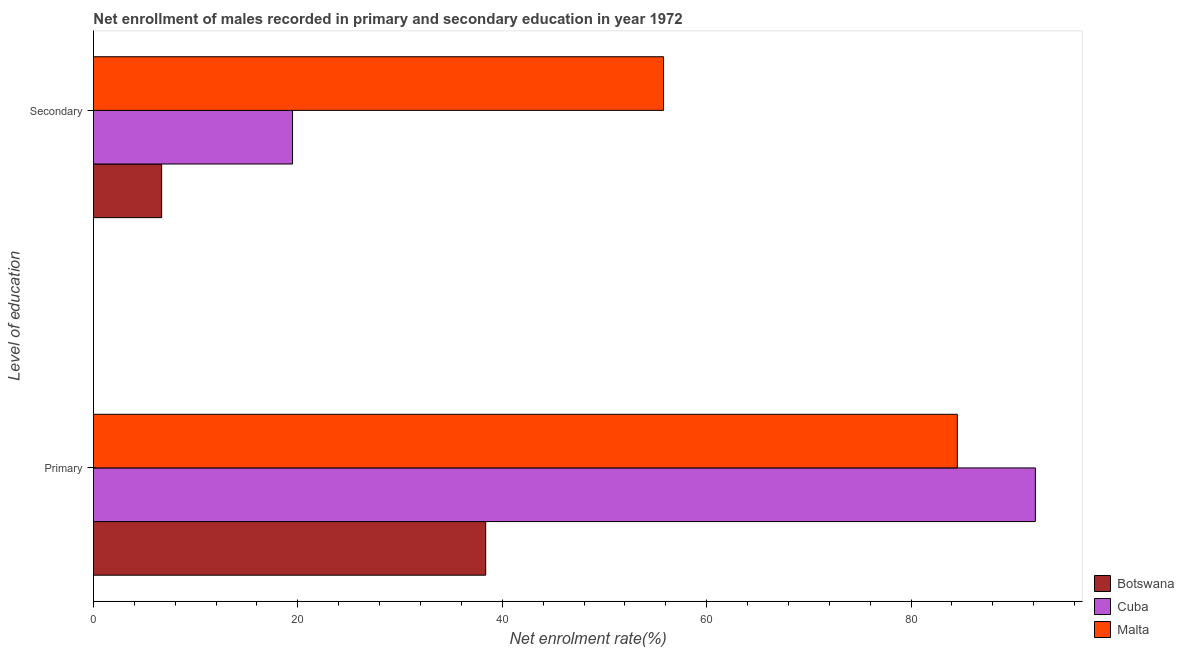How many different coloured bars are there?
Give a very brief answer. 3. How many groups of bars are there?
Your answer should be compact. 2. Are the number of bars on each tick of the Y-axis equal?
Provide a short and direct response. Yes. How many bars are there on the 2nd tick from the top?
Your answer should be very brief. 3. What is the label of the 1st group of bars from the top?
Give a very brief answer. Secondary. What is the enrollment rate in secondary education in Cuba?
Give a very brief answer. 19.48. Across all countries, what is the maximum enrollment rate in secondary education?
Provide a short and direct response. 55.78. Across all countries, what is the minimum enrollment rate in secondary education?
Ensure brevity in your answer.  6.67. In which country was the enrollment rate in secondary education maximum?
Give a very brief answer. Malta. In which country was the enrollment rate in secondary education minimum?
Ensure brevity in your answer.  Botswana. What is the total enrollment rate in secondary education in the graph?
Your answer should be very brief. 81.93. What is the difference between the enrollment rate in secondary education in Malta and that in Botswana?
Offer a terse response. 49.11. What is the difference between the enrollment rate in secondary education in Malta and the enrollment rate in primary education in Botswana?
Provide a succinct answer. 17.4. What is the average enrollment rate in secondary education per country?
Make the answer very short. 27.31. What is the difference between the enrollment rate in primary education and enrollment rate in secondary education in Malta?
Keep it short and to the point. 28.74. In how many countries, is the enrollment rate in secondary education greater than 4 %?
Offer a terse response. 3. What is the ratio of the enrollment rate in primary education in Malta to that in Botswana?
Your answer should be very brief. 2.2. Is the enrollment rate in secondary education in Cuba less than that in Botswana?
Make the answer very short. No. In how many countries, is the enrollment rate in primary education greater than the average enrollment rate in primary education taken over all countries?
Give a very brief answer. 2. What does the 1st bar from the top in Secondary represents?
Give a very brief answer. Malta. What does the 3rd bar from the bottom in Secondary represents?
Offer a very short reply. Malta. How many bars are there?
Your response must be concise. 6. How many countries are there in the graph?
Ensure brevity in your answer.  3. What is the difference between two consecutive major ticks on the X-axis?
Offer a very short reply. 20. Are the values on the major ticks of X-axis written in scientific E-notation?
Make the answer very short. No. Does the graph contain grids?
Provide a short and direct response. No. Where does the legend appear in the graph?
Your answer should be compact. Bottom right. How many legend labels are there?
Keep it short and to the point. 3. What is the title of the graph?
Offer a terse response. Net enrollment of males recorded in primary and secondary education in year 1972. What is the label or title of the X-axis?
Provide a succinct answer. Net enrolment rate(%). What is the label or title of the Y-axis?
Your response must be concise. Level of education. What is the Net enrolment rate(%) of Botswana in Primary?
Your answer should be very brief. 38.38. What is the Net enrolment rate(%) of Cuba in Primary?
Provide a succinct answer. 92.16. What is the Net enrolment rate(%) of Malta in Primary?
Your answer should be very brief. 84.52. What is the Net enrolment rate(%) of Botswana in Secondary?
Keep it short and to the point. 6.67. What is the Net enrolment rate(%) in Cuba in Secondary?
Provide a short and direct response. 19.48. What is the Net enrolment rate(%) of Malta in Secondary?
Give a very brief answer. 55.78. Across all Level of education, what is the maximum Net enrolment rate(%) of Botswana?
Offer a terse response. 38.38. Across all Level of education, what is the maximum Net enrolment rate(%) in Cuba?
Provide a short and direct response. 92.16. Across all Level of education, what is the maximum Net enrolment rate(%) of Malta?
Make the answer very short. 84.52. Across all Level of education, what is the minimum Net enrolment rate(%) in Botswana?
Your response must be concise. 6.67. Across all Level of education, what is the minimum Net enrolment rate(%) of Cuba?
Provide a succinct answer. 19.48. Across all Level of education, what is the minimum Net enrolment rate(%) of Malta?
Provide a succinct answer. 55.78. What is the total Net enrolment rate(%) in Botswana in the graph?
Offer a terse response. 45.05. What is the total Net enrolment rate(%) in Cuba in the graph?
Your response must be concise. 111.64. What is the total Net enrolment rate(%) in Malta in the graph?
Provide a short and direct response. 140.3. What is the difference between the Net enrolment rate(%) in Botswana in Primary and that in Secondary?
Offer a very short reply. 31.71. What is the difference between the Net enrolment rate(%) in Cuba in Primary and that in Secondary?
Provide a short and direct response. 72.69. What is the difference between the Net enrolment rate(%) of Malta in Primary and that in Secondary?
Your answer should be very brief. 28.74. What is the difference between the Net enrolment rate(%) in Botswana in Primary and the Net enrolment rate(%) in Cuba in Secondary?
Your answer should be very brief. 18.9. What is the difference between the Net enrolment rate(%) of Botswana in Primary and the Net enrolment rate(%) of Malta in Secondary?
Keep it short and to the point. -17.4. What is the difference between the Net enrolment rate(%) in Cuba in Primary and the Net enrolment rate(%) in Malta in Secondary?
Your answer should be compact. 36.38. What is the average Net enrolment rate(%) in Botswana per Level of education?
Provide a succinct answer. 22.52. What is the average Net enrolment rate(%) in Cuba per Level of education?
Offer a terse response. 55.82. What is the average Net enrolment rate(%) in Malta per Level of education?
Your answer should be very brief. 70.15. What is the difference between the Net enrolment rate(%) in Botswana and Net enrolment rate(%) in Cuba in Primary?
Your answer should be compact. -53.78. What is the difference between the Net enrolment rate(%) in Botswana and Net enrolment rate(%) in Malta in Primary?
Ensure brevity in your answer.  -46.15. What is the difference between the Net enrolment rate(%) in Cuba and Net enrolment rate(%) in Malta in Primary?
Your response must be concise. 7.64. What is the difference between the Net enrolment rate(%) of Botswana and Net enrolment rate(%) of Cuba in Secondary?
Your answer should be very brief. -12.81. What is the difference between the Net enrolment rate(%) in Botswana and Net enrolment rate(%) in Malta in Secondary?
Ensure brevity in your answer.  -49.11. What is the difference between the Net enrolment rate(%) in Cuba and Net enrolment rate(%) in Malta in Secondary?
Your answer should be compact. -36.3. What is the ratio of the Net enrolment rate(%) of Botswana in Primary to that in Secondary?
Make the answer very short. 5.75. What is the ratio of the Net enrolment rate(%) in Cuba in Primary to that in Secondary?
Your response must be concise. 4.73. What is the ratio of the Net enrolment rate(%) of Malta in Primary to that in Secondary?
Provide a short and direct response. 1.52. What is the difference between the highest and the second highest Net enrolment rate(%) of Botswana?
Ensure brevity in your answer.  31.71. What is the difference between the highest and the second highest Net enrolment rate(%) of Cuba?
Offer a very short reply. 72.69. What is the difference between the highest and the second highest Net enrolment rate(%) of Malta?
Your answer should be compact. 28.74. What is the difference between the highest and the lowest Net enrolment rate(%) in Botswana?
Your response must be concise. 31.71. What is the difference between the highest and the lowest Net enrolment rate(%) in Cuba?
Give a very brief answer. 72.69. What is the difference between the highest and the lowest Net enrolment rate(%) in Malta?
Your answer should be very brief. 28.74. 